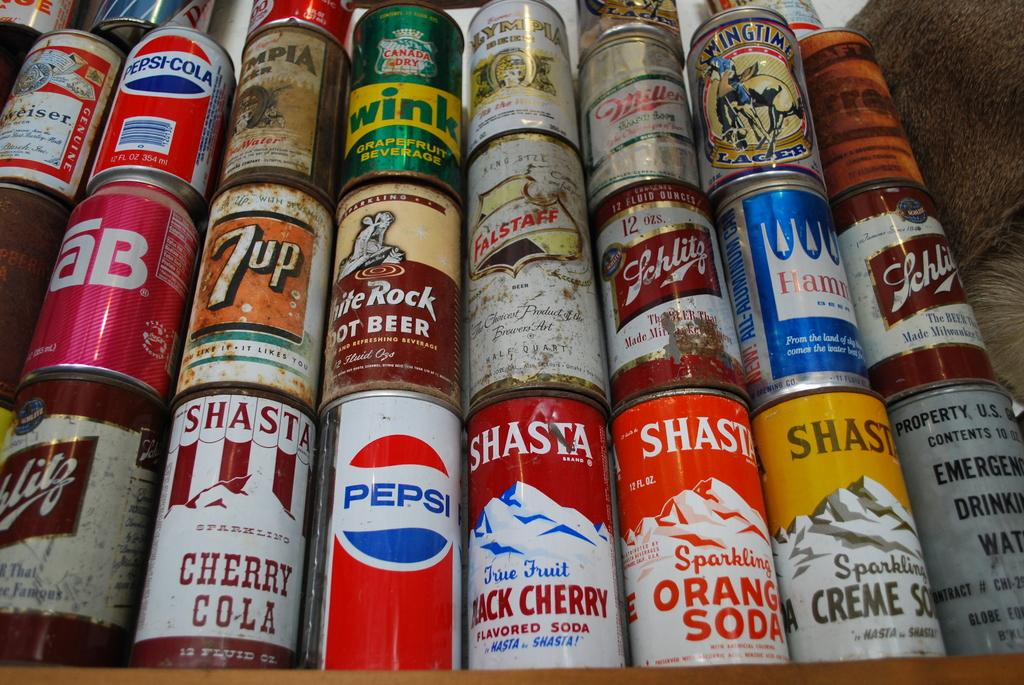<image>
Give a short and clear explanation of the subsequent image. Cans are stacked on top of each other including ones from Pepsi, Shasta, and Tab. 